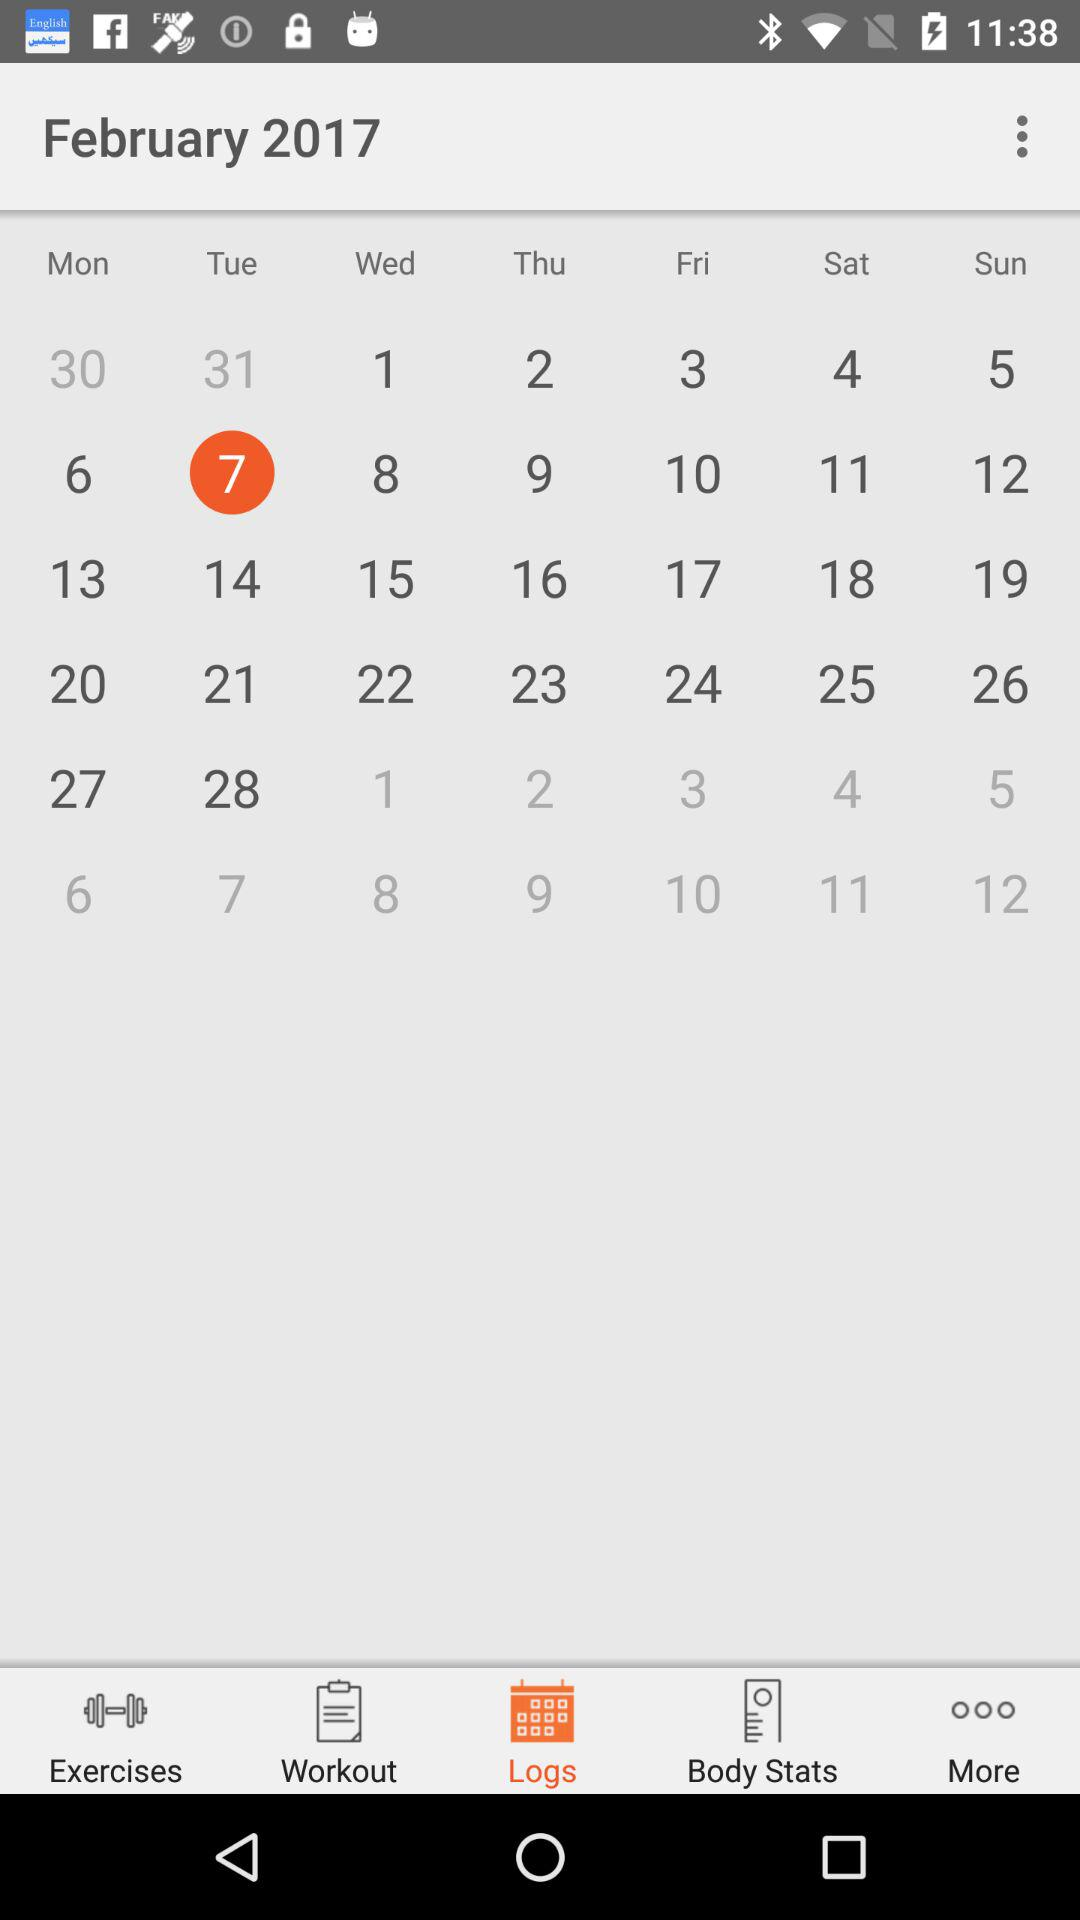Which month of the calendar is open? The month of the calendar that is open is February. 